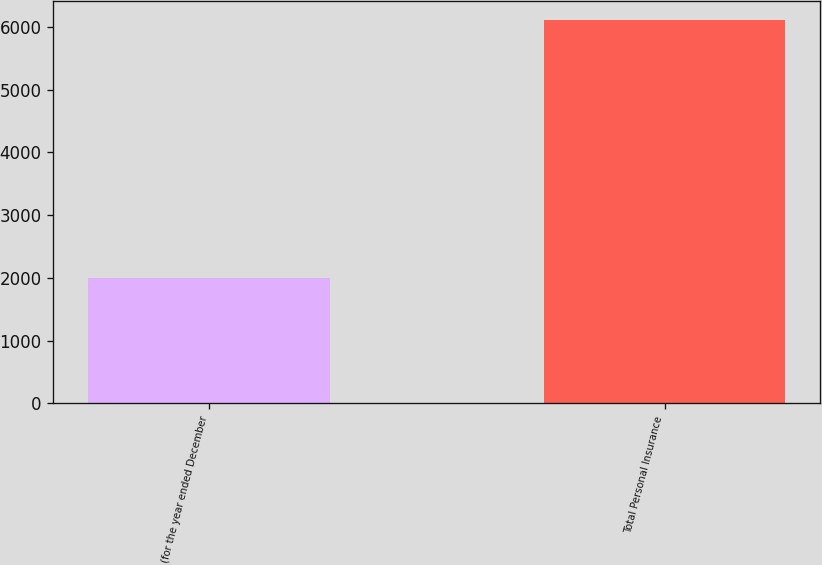Convert chart. <chart><loc_0><loc_0><loc_500><loc_500><bar_chart><fcel>(for the year ended December<fcel>Total Personal Insurance<nl><fcel>2004<fcel>6111<nl></chart> 